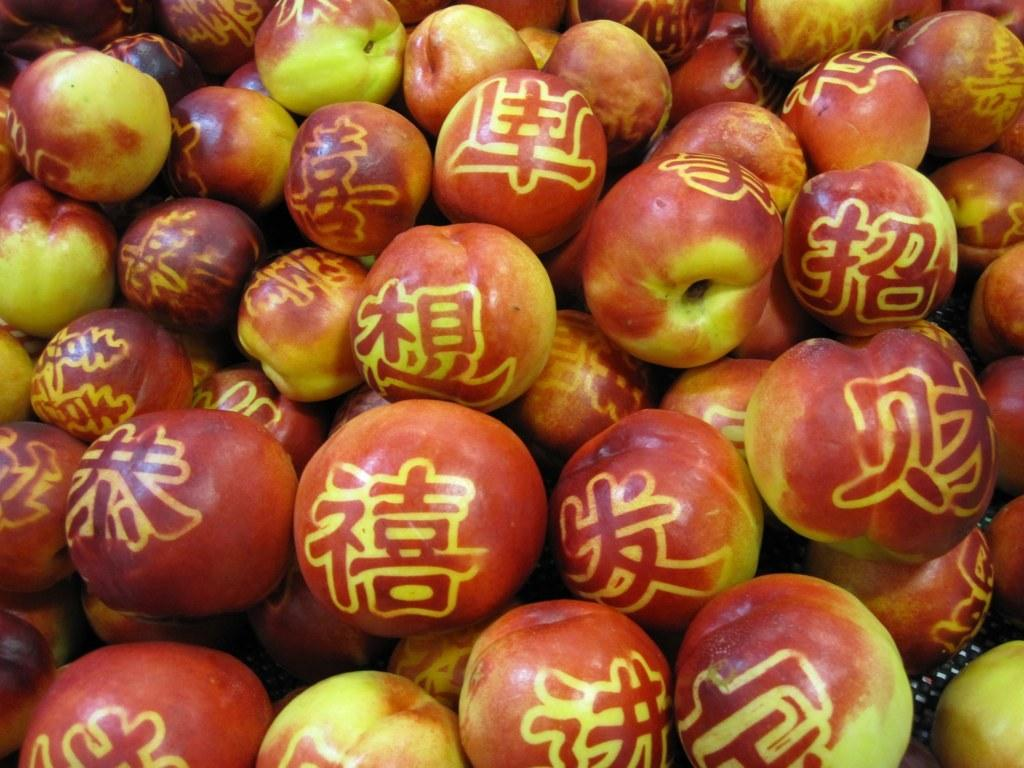What type of fruit is visible in the image? There are red color apples in the image. Can you see a woman holding a net to catch a bear in the image? No, there is no woman, net, or bear present in the image; it only features red color apples. 